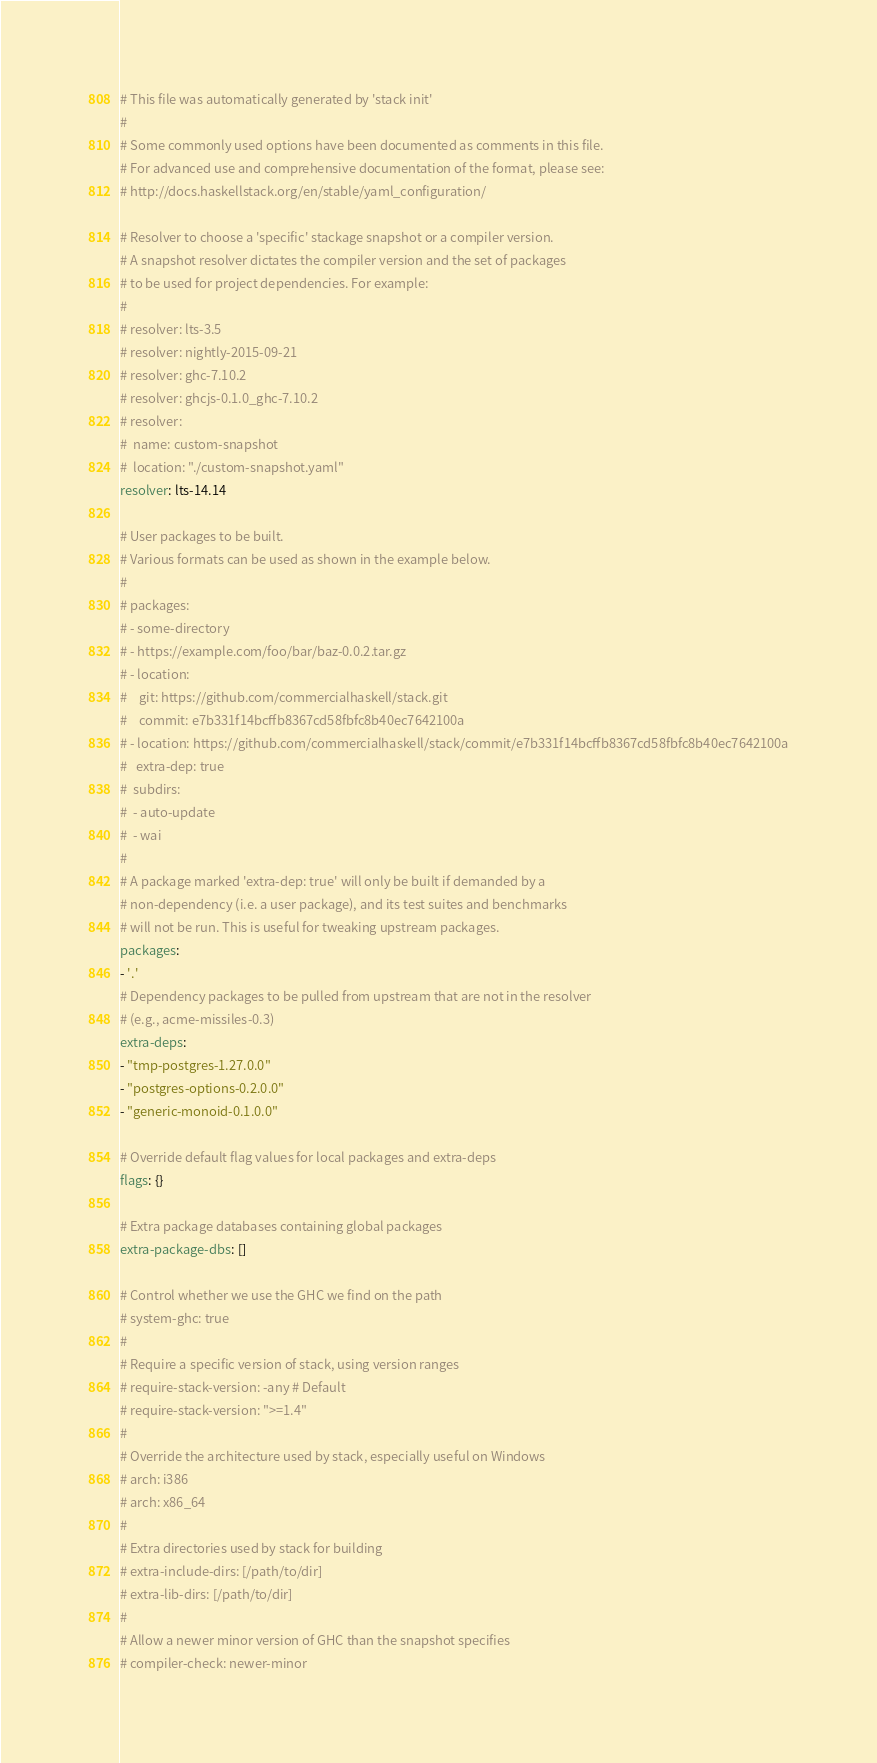<code> <loc_0><loc_0><loc_500><loc_500><_YAML_># This file was automatically generated by 'stack init'
#
# Some commonly used options have been documented as comments in this file.
# For advanced use and comprehensive documentation of the format, please see:
# http://docs.haskellstack.org/en/stable/yaml_configuration/

# Resolver to choose a 'specific' stackage snapshot or a compiler version.
# A snapshot resolver dictates the compiler version and the set of packages
# to be used for project dependencies. For example:
#
# resolver: lts-3.5
# resolver: nightly-2015-09-21
# resolver: ghc-7.10.2
# resolver: ghcjs-0.1.0_ghc-7.10.2
# resolver:
#  name: custom-snapshot
#  location: "./custom-snapshot.yaml"
resolver: lts-14.14

# User packages to be built.
# Various formats can be used as shown in the example below.
#
# packages:
# - some-directory
# - https://example.com/foo/bar/baz-0.0.2.tar.gz
# - location:
#    git: https://github.com/commercialhaskell/stack.git
#    commit: e7b331f14bcffb8367cd58fbfc8b40ec7642100a
# - location: https://github.com/commercialhaskell/stack/commit/e7b331f14bcffb8367cd58fbfc8b40ec7642100a
#   extra-dep: true
#  subdirs:
#  - auto-update
#  - wai
#
# A package marked 'extra-dep: true' will only be built if demanded by a
# non-dependency (i.e. a user package), and its test suites and benchmarks
# will not be run. This is useful for tweaking upstream packages.
packages:
- '.'
# Dependency packages to be pulled from upstream that are not in the resolver
# (e.g., acme-missiles-0.3)
extra-deps:
- "tmp-postgres-1.27.0.0"
- "postgres-options-0.2.0.0"
- "generic-monoid-0.1.0.0"

# Override default flag values for local packages and extra-deps
flags: {}

# Extra package databases containing global packages
extra-package-dbs: []

# Control whether we use the GHC we find on the path
# system-ghc: true
#
# Require a specific version of stack, using version ranges
# require-stack-version: -any # Default
# require-stack-version: ">=1.4"
#
# Override the architecture used by stack, especially useful on Windows
# arch: i386
# arch: x86_64
#
# Extra directories used by stack for building
# extra-include-dirs: [/path/to/dir]
# extra-lib-dirs: [/path/to/dir]
#
# Allow a newer minor version of GHC than the snapshot specifies
# compiler-check: newer-minor
</code> 